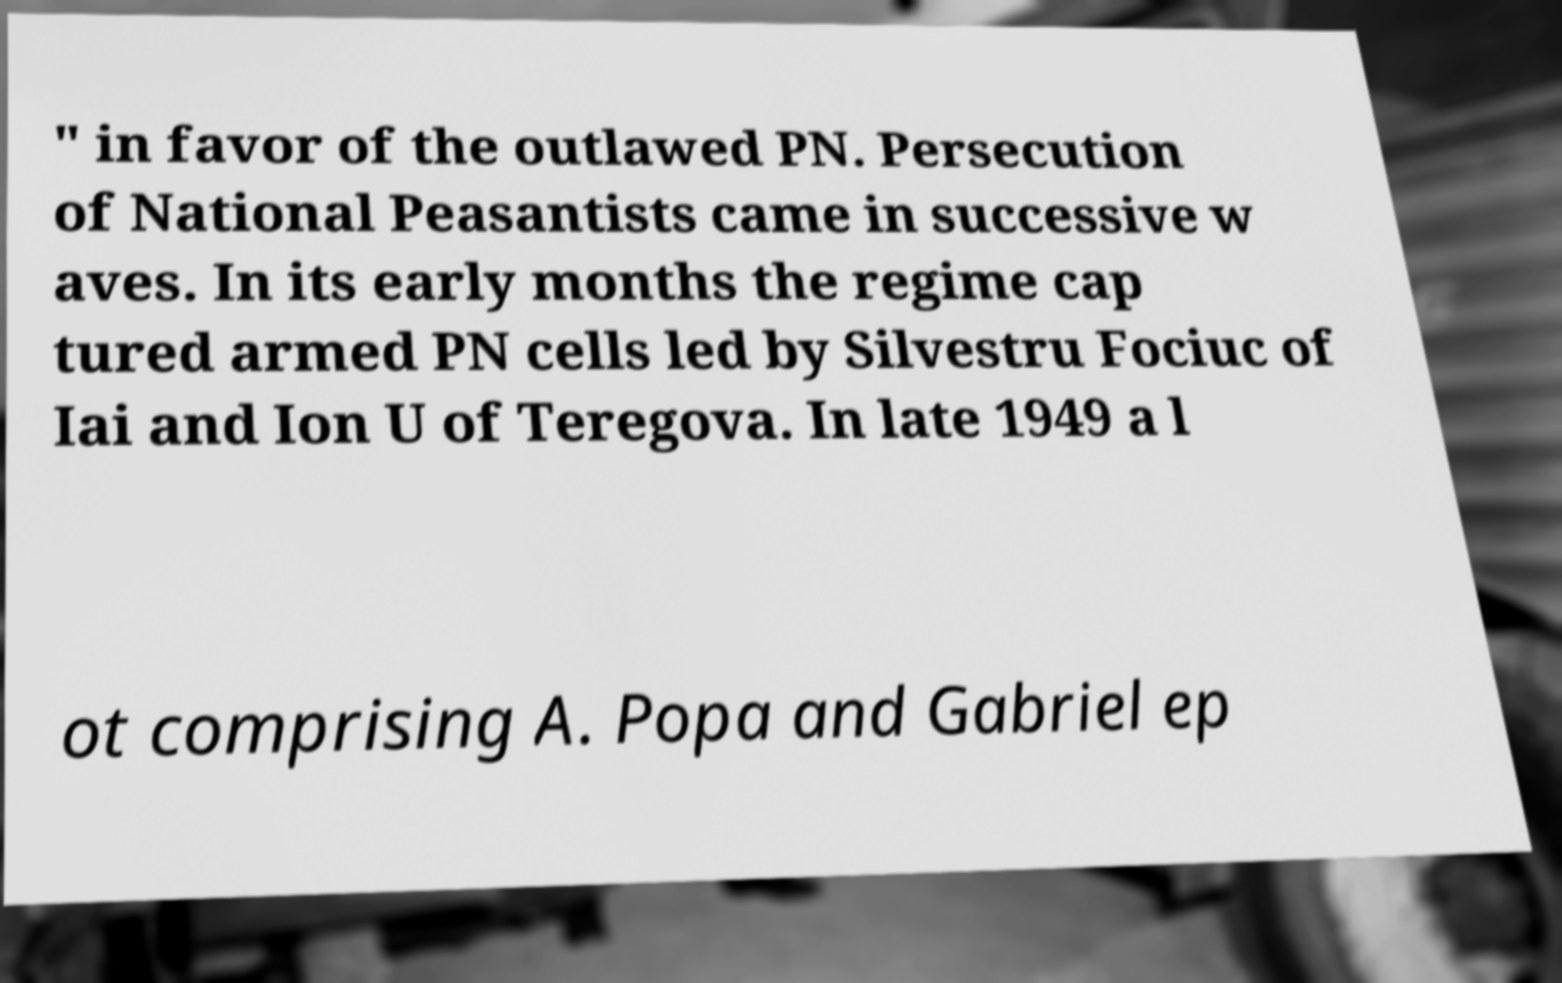Could you assist in decoding the text presented in this image and type it out clearly? " in favor of the outlawed PN. Persecution of National Peasantists came in successive w aves. In its early months the regime cap tured armed PN cells led by Silvestru Fociuc of Iai and Ion U of Teregova. In late 1949 a l ot comprising A. Popa and Gabriel ep 